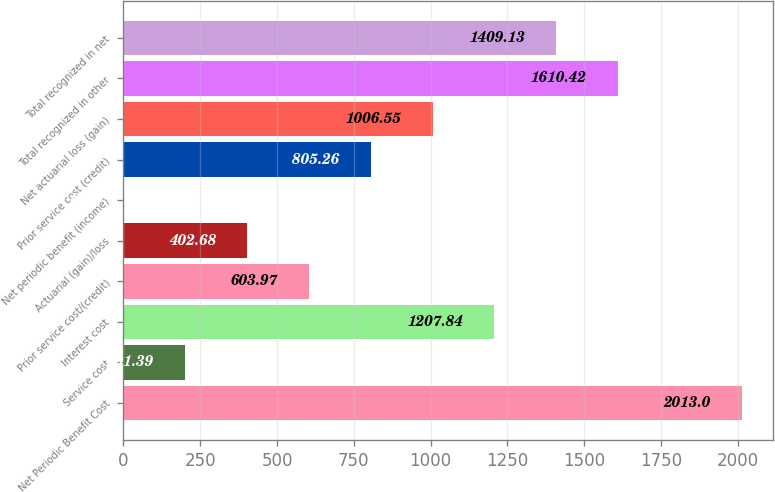Convert chart. <chart><loc_0><loc_0><loc_500><loc_500><bar_chart><fcel>Net Periodic Benefit Cost<fcel>Service cost<fcel>Interest cost<fcel>Prior service cost/(credit)<fcel>Actuarial (gain)/loss<fcel>Net periodic benefit (income)<fcel>Prior service cost (credit)<fcel>Net actuarial loss (gain)<fcel>Total recognized in other<fcel>Total recognized in net<nl><fcel>2013<fcel>201.39<fcel>1207.84<fcel>603.97<fcel>402.68<fcel>0.1<fcel>805.26<fcel>1006.55<fcel>1610.42<fcel>1409.13<nl></chart> 